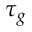<formula> <loc_0><loc_0><loc_500><loc_500>\tau _ { g }</formula> 